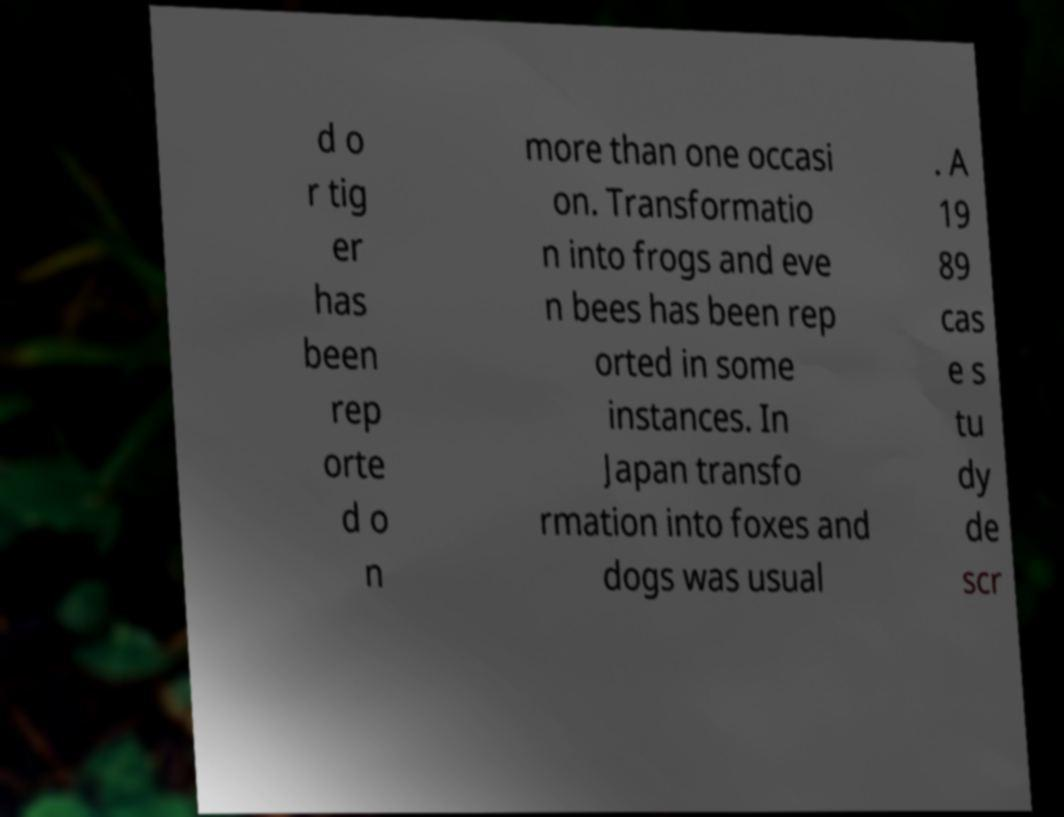Please identify and transcribe the text found in this image. d o r tig er has been rep orte d o n more than one occasi on. Transformatio n into frogs and eve n bees has been rep orted in some instances. In Japan transfo rmation into foxes and dogs was usual . A 19 89 cas e s tu dy de scr 